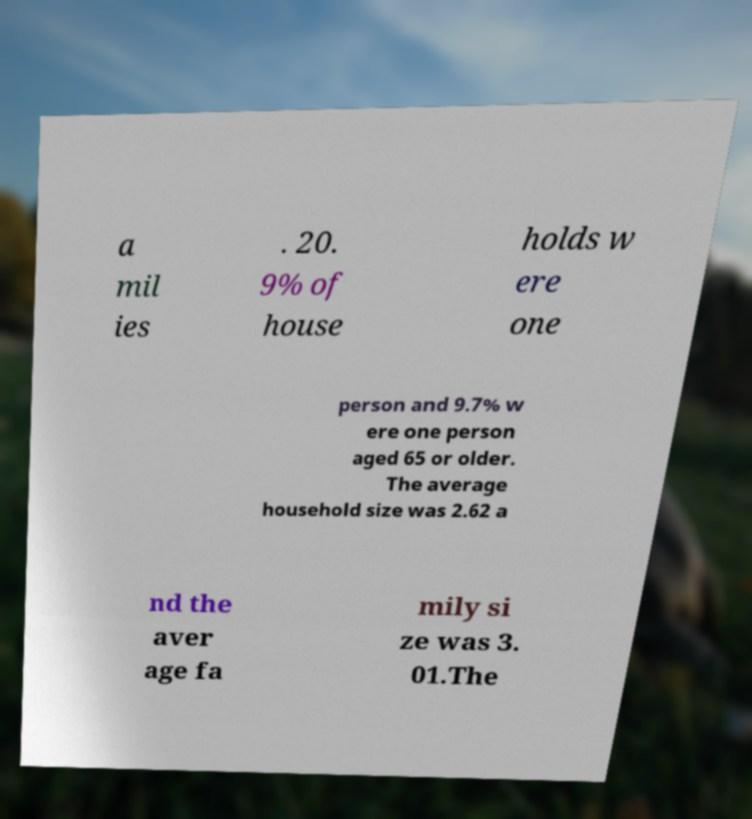For documentation purposes, I need the text within this image transcribed. Could you provide that? a mil ies . 20. 9% of house holds w ere one person and 9.7% w ere one person aged 65 or older. The average household size was 2.62 a nd the aver age fa mily si ze was 3. 01.The 